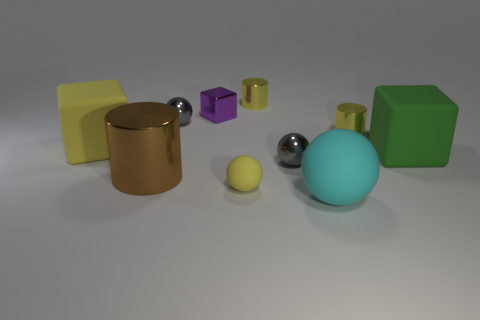Subtract 1 cylinders. How many cylinders are left? 2 Subtract all cyan balls. How many balls are left? 3 Subtract all yellow balls. How many balls are left? 3 Subtract all green spheres. Subtract all blue cylinders. How many spheres are left? 4 Subtract all spheres. How many objects are left? 6 Subtract all big green matte blocks. Subtract all small yellow cylinders. How many objects are left? 7 Add 7 big cyan rubber objects. How many big cyan rubber objects are left? 8 Add 2 large blue rubber things. How many large blue rubber things exist? 2 Subtract 1 green cubes. How many objects are left? 9 